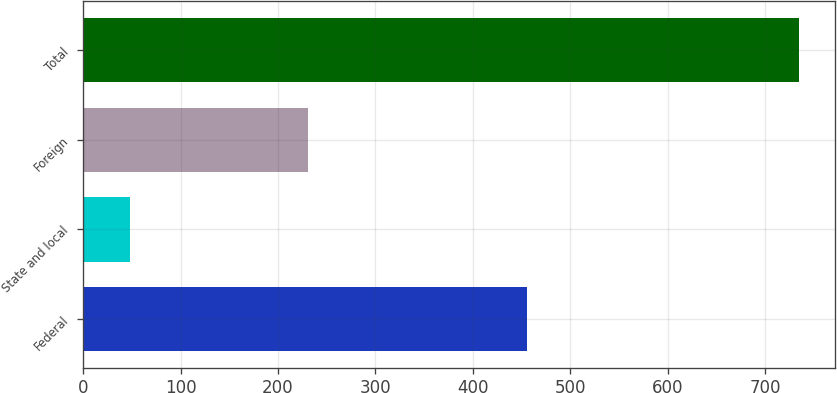<chart> <loc_0><loc_0><loc_500><loc_500><bar_chart><fcel>Federal<fcel>State and local<fcel>Foreign<fcel>Total<nl><fcel>456<fcel>48<fcel>231<fcel>735<nl></chart> 